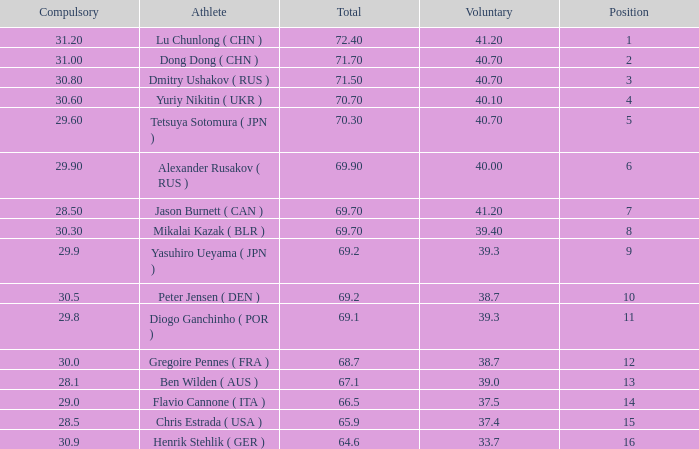What's the total of the position of 1? None. 